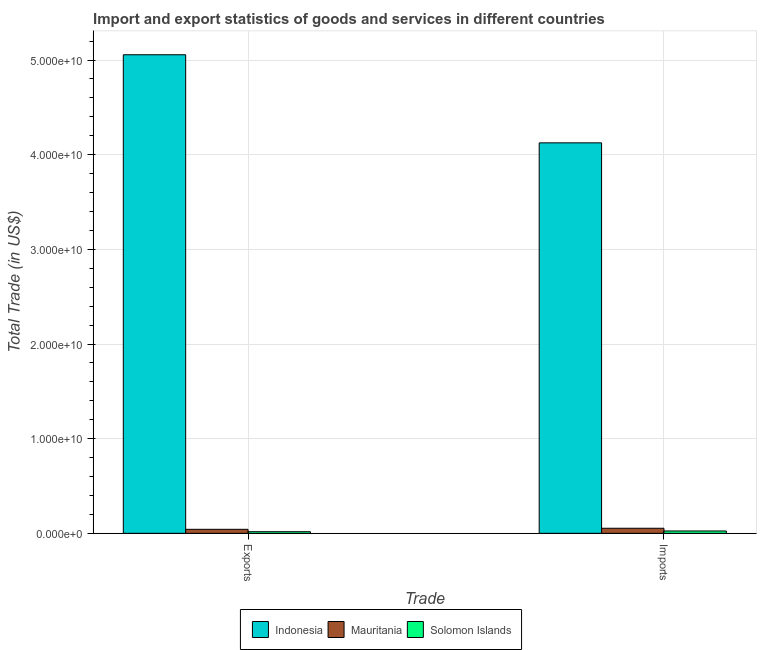How many groups of bars are there?
Provide a succinct answer. 2. Are the number of bars per tick equal to the number of legend labels?
Give a very brief answer. Yes. Are the number of bars on each tick of the X-axis equal?
Ensure brevity in your answer.  Yes. What is the label of the 1st group of bars from the left?
Your response must be concise. Exports. What is the export of goods and services in Solomon Islands?
Ensure brevity in your answer.  1.71e+08. Across all countries, what is the maximum export of goods and services?
Give a very brief answer. 5.06e+1. Across all countries, what is the minimum export of goods and services?
Your answer should be very brief. 1.71e+08. In which country was the export of goods and services maximum?
Keep it short and to the point. Indonesia. In which country was the imports of goods and services minimum?
Make the answer very short. Solomon Islands. What is the total export of goods and services in the graph?
Offer a terse response. 5.12e+1. What is the difference between the imports of goods and services in Solomon Islands and that in Indonesia?
Your response must be concise. -4.10e+1. What is the difference between the export of goods and services in Indonesia and the imports of goods and services in Mauritania?
Provide a short and direct response. 5.00e+1. What is the average export of goods and services per country?
Make the answer very short. 1.71e+1. What is the difference between the imports of goods and services and export of goods and services in Mauritania?
Provide a succinct answer. 1.12e+08. What is the ratio of the export of goods and services in Indonesia to that in Mauritania?
Provide a short and direct response. 119.15. Is the export of goods and services in Indonesia less than that in Solomon Islands?
Make the answer very short. No. In how many countries, is the imports of goods and services greater than the average imports of goods and services taken over all countries?
Ensure brevity in your answer.  1. What does the 1st bar from the left in Exports represents?
Your response must be concise. Indonesia. What does the 2nd bar from the right in Imports represents?
Your answer should be very brief. Mauritania. What is the difference between two consecutive major ticks on the Y-axis?
Keep it short and to the point. 1.00e+1. Are the values on the major ticks of Y-axis written in scientific E-notation?
Your response must be concise. Yes. Does the graph contain any zero values?
Provide a succinct answer. No. Does the graph contain grids?
Your response must be concise. Yes. Where does the legend appear in the graph?
Provide a short and direct response. Bottom center. How are the legend labels stacked?
Your answer should be very brief. Horizontal. What is the title of the graph?
Offer a very short reply. Import and export statistics of goods and services in different countries. What is the label or title of the X-axis?
Offer a terse response. Trade. What is the label or title of the Y-axis?
Offer a terse response. Total Trade (in US$). What is the Total Trade (in US$) in Indonesia in Exports?
Your answer should be compact. 5.06e+1. What is the Total Trade (in US$) in Mauritania in Exports?
Offer a terse response. 4.24e+08. What is the Total Trade (in US$) in Solomon Islands in Exports?
Offer a terse response. 1.71e+08. What is the Total Trade (in US$) in Indonesia in Imports?
Provide a short and direct response. 4.12e+1. What is the Total Trade (in US$) in Mauritania in Imports?
Provide a short and direct response. 5.36e+08. What is the Total Trade (in US$) in Solomon Islands in Imports?
Offer a terse response. 2.48e+08. Across all Trade, what is the maximum Total Trade (in US$) in Indonesia?
Keep it short and to the point. 5.06e+1. Across all Trade, what is the maximum Total Trade (in US$) of Mauritania?
Offer a terse response. 5.36e+08. Across all Trade, what is the maximum Total Trade (in US$) in Solomon Islands?
Offer a terse response. 2.48e+08. Across all Trade, what is the minimum Total Trade (in US$) in Indonesia?
Provide a succinct answer. 4.12e+1. Across all Trade, what is the minimum Total Trade (in US$) of Mauritania?
Your answer should be very brief. 4.24e+08. Across all Trade, what is the minimum Total Trade (in US$) of Solomon Islands?
Ensure brevity in your answer.  1.71e+08. What is the total Total Trade (in US$) in Indonesia in the graph?
Offer a terse response. 9.18e+1. What is the total Total Trade (in US$) in Mauritania in the graph?
Offer a terse response. 9.61e+08. What is the total Total Trade (in US$) in Solomon Islands in the graph?
Your answer should be very brief. 4.19e+08. What is the difference between the Total Trade (in US$) of Indonesia in Exports and that in Imports?
Your answer should be very brief. 9.31e+09. What is the difference between the Total Trade (in US$) of Mauritania in Exports and that in Imports?
Make the answer very short. -1.12e+08. What is the difference between the Total Trade (in US$) in Solomon Islands in Exports and that in Imports?
Ensure brevity in your answer.  -7.77e+07. What is the difference between the Total Trade (in US$) of Indonesia in Exports and the Total Trade (in US$) of Mauritania in Imports?
Your answer should be compact. 5.00e+1. What is the difference between the Total Trade (in US$) in Indonesia in Exports and the Total Trade (in US$) in Solomon Islands in Imports?
Keep it short and to the point. 5.03e+1. What is the difference between the Total Trade (in US$) in Mauritania in Exports and the Total Trade (in US$) in Solomon Islands in Imports?
Your answer should be compact. 1.76e+08. What is the average Total Trade (in US$) of Indonesia per Trade?
Your answer should be compact. 4.59e+1. What is the average Total Trade (in US$) of Mauritania per Trade?
Your response must be concise. 4.80e+08. What is the average Total Trade (in US$) in Solomon Islands per Trade?
Keep it short and to the point. 2.09e+08. What is the difference between the Total Trade (in US$) in Indonesia and Total Trade (in US$) in Mauritania in Exports?
Provide a succinct answer. 5.01e+1. What is the difference between the Total Trade (in US$) in Indonesia and Total Trade (in US$) in Solomon Islands in Exports?
Provide a short and direct response. 5.04e+1. What is the difference between the Total Trade (in US$) of Mauritania and Total Trade (in US$) of Solomon Islands in Exports?
Your answer should be very brief. 2.54e+08. What is the difference between the Total Trade (in US$) of Indonesia and Total Trade (in US$) of Mauritania in Imports?
Offer a very short reply. 4.07e+1. What is the difference between the Total Trade (in US$) of Indonesia and Total Trade (in US$) of Solomon Islands in Imports?
Provide a succinct answer. 4.10e+1. What is the difference between the Total Trade (in US$) in Mauritania and Total Trade (in US$) in Solomon Islands in Imports?
Provide a short and direct response. 2.88e+08. What is the ratio of the Total Trade (in US$) of Indonesia in Exports to that in Imports?
Your answer should be compact. 1.23. What is the ratio of the Total Trade (in US$) in Mauritania in Exports to that in Imports?
Keep it short and to the point. 0.79. What is the ratio of the Total Trade (in US$) of Solomon Islands in Exports to that in Imports?
Your answer should be compact. 0.69. What is the difference between the highest and the second highest Total Trade (in US$) of Indonesia?
Provide a succinct answer. 9.31e+09. What is the difference between the highest and the second highest Total Trade (in US$) in Mauritania?
Your response must be concise. 1.12e+08. What is the difference between the highest and the second highest Total Trade (in US$) in Solomon Islands?
Your response must be concise. 7.77e+07. What is the difference between the highest and the lowest Total Trade (in US$) in Indonesia?
Your answer should be very brief. 9.31e+09. What is the difference between the highest and the lowest Total Trade (in US$) of Mauritania?
Your answer should be very brief. 1.12e+08. What is the difference between the highest and the lowest Total Trade (in US$) of Solomon Islands?
Make the answer very short. 7.77e+07. 